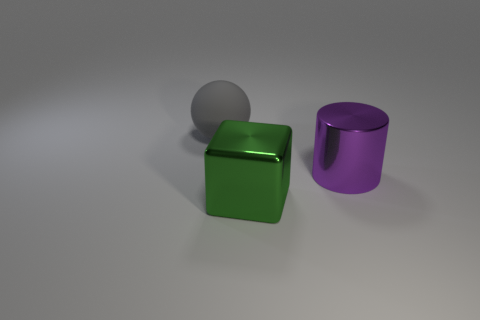Add 2 gray objects. How many objects exist? 5 Subtract all balls. How many objects are left? 2 Subtract 1 balls. How many balls are left? 0 Subtract all red cylinders. Subtract all yellow spheres. How many cylinders are left? 1 Subtract all brown blocks. How many red spheres are left? 0 Subtract all large metallic things. Subtract all big gray rubber balls. How many objects are left? 0 Add 1 green metal things. How many green metal things are left? 2 Add 3 large purple shiny things. How many large purple shiny things exist? 4 Subtract 0 brown blocks. How many objects are left? 3 